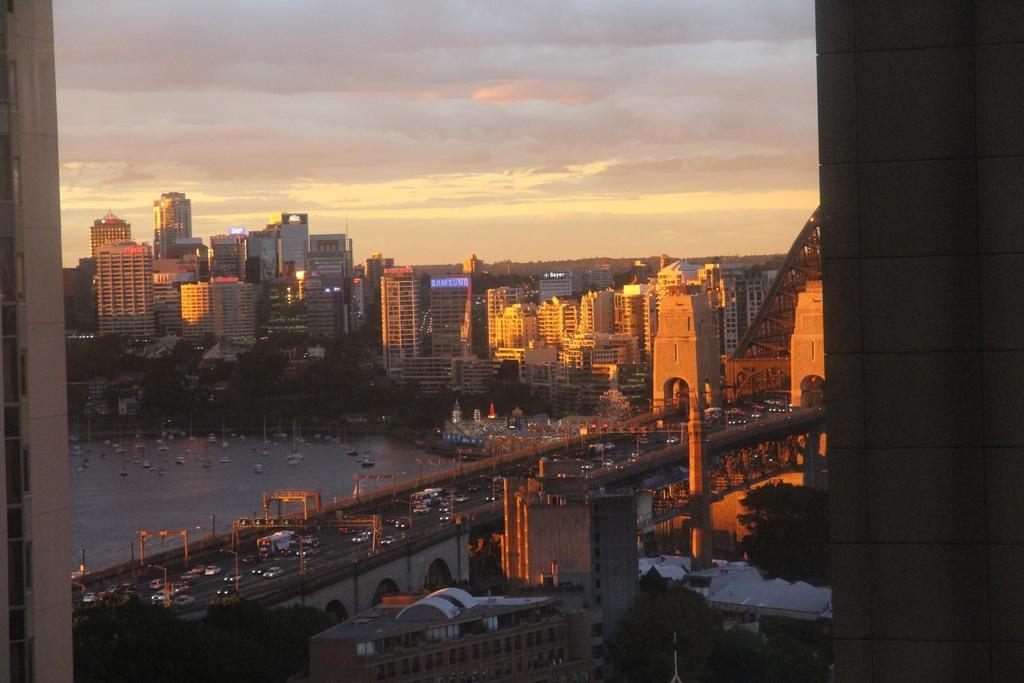Can you describe this image briefly? This image consists of many buildings and skyscrapers. In the front, we can see a bridge on which there are many vehicles. At the bottom, there is water in which there are boats. On the right, there are trees. At the top, there are clouds in the sky. And we can see a wall on the right. 